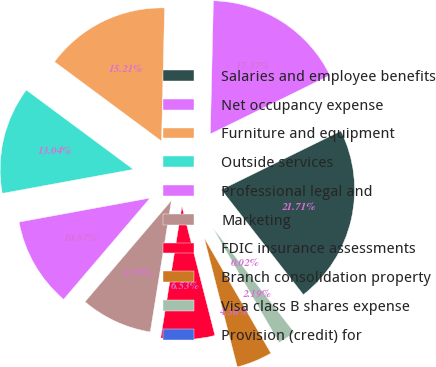Convert chart. <chart><loc_0><loc_0><loc_500><loc_500><pie_chart><fcel>Salaries and employee benefits<fcel>Net occupancy expense<fcel>Furniture and equipment<fcel>Outside services<fcel>Professional legal and<fcel>Marketing<fcel>FDIC insurance assessments<fcel>Branch consolidation property<fcel>Visa class B shares expense<fcel>Provision (credit) for<nl><fcel>21.71%<fcel>17.37%<fcel>15.21%<fcel>13.04%<fcel>10.87%<fcel>8.7%<fcel>6.53%<fcel>4.36%<fcel>2.19%<fcel>0.02%<nl></chart> 